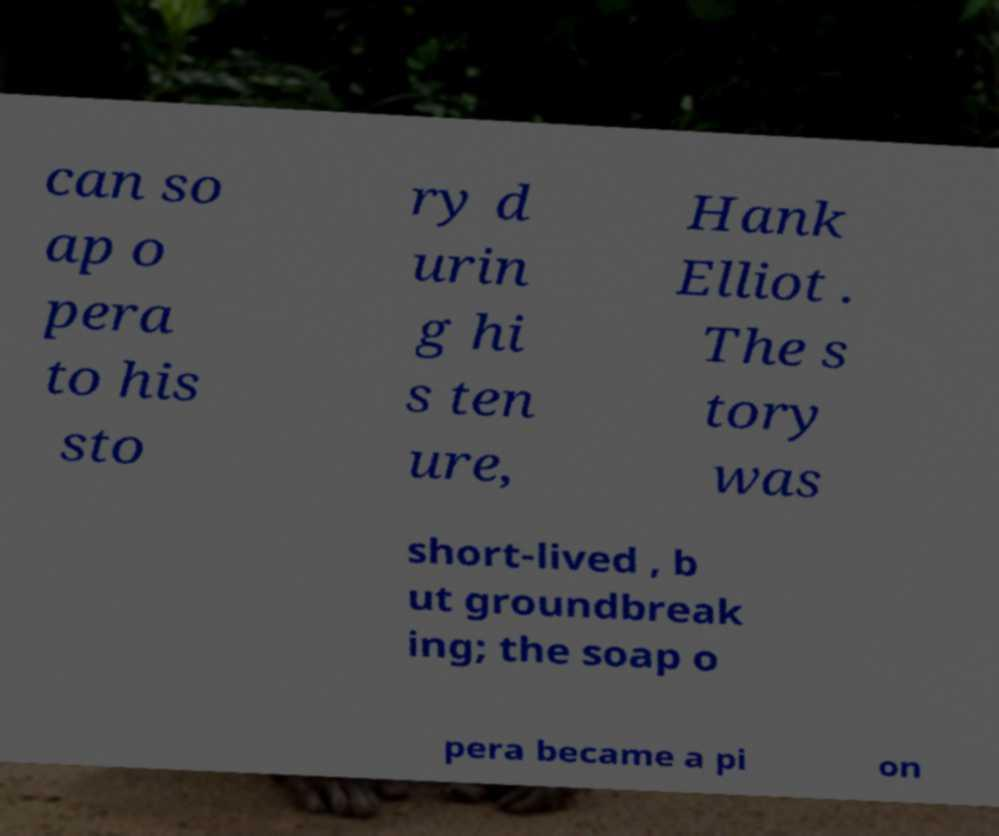Could you extract and type out the text from this image? can so ap o pera to his sto ry d urin g hi s ten ure, Hank Elliot . The s tory was short-lived , b ut groundbreak ing; the soap o pera became a pi on 